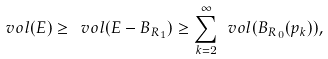Convert formula to latex. <formula><loc_0><loc_0><loc_500><loc_500>\ v o l ( E ) \geq \ v o l ( E - B _ { R _ { 1 } } ) \geq \sum _ { k = 2 } ^ { \infty } \ v o l ( B _ { R _ { 0 } } ( p _ { k } ) ) ,</formula> 